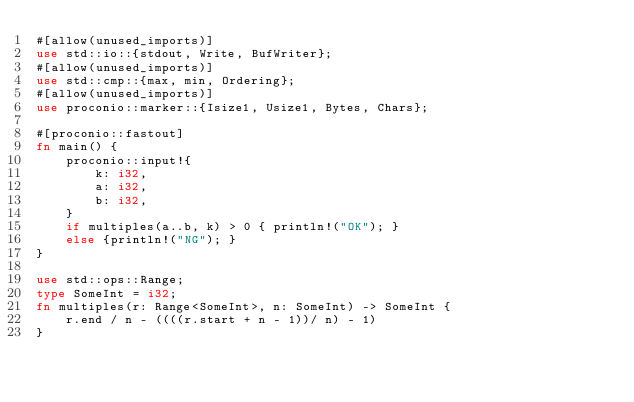Convert code to text. <code><loc_0><loc_0><loc_500><loc_500><_Rust_>#[allow(unused_imports)]
use std::io::{stdout, Write, BufWriter};
#[allow(unused_imports)]
use std::cmp::{max, min, Ordering};
#[allow(unused_imports)]
use proconio::marker::{Isize1, Usize1, Bytes, Chars};

#[proconio::fastout]
fn main() {
    proconio::input!{
        k: i32,
        a: i32,
        b: i32,
    }
    if multiples(a..b, k) > 0 { println!("OK"); }
    else {println!("NG"); }
}

use std::ops::Range;
type SomeInt = i32;
fn multiples(r: Range<SomeInt>, n: SomeInt) -> SomeInt {
    r.end / n - ((((r.start + n - 1))/ n) - 1)
}

</code> 